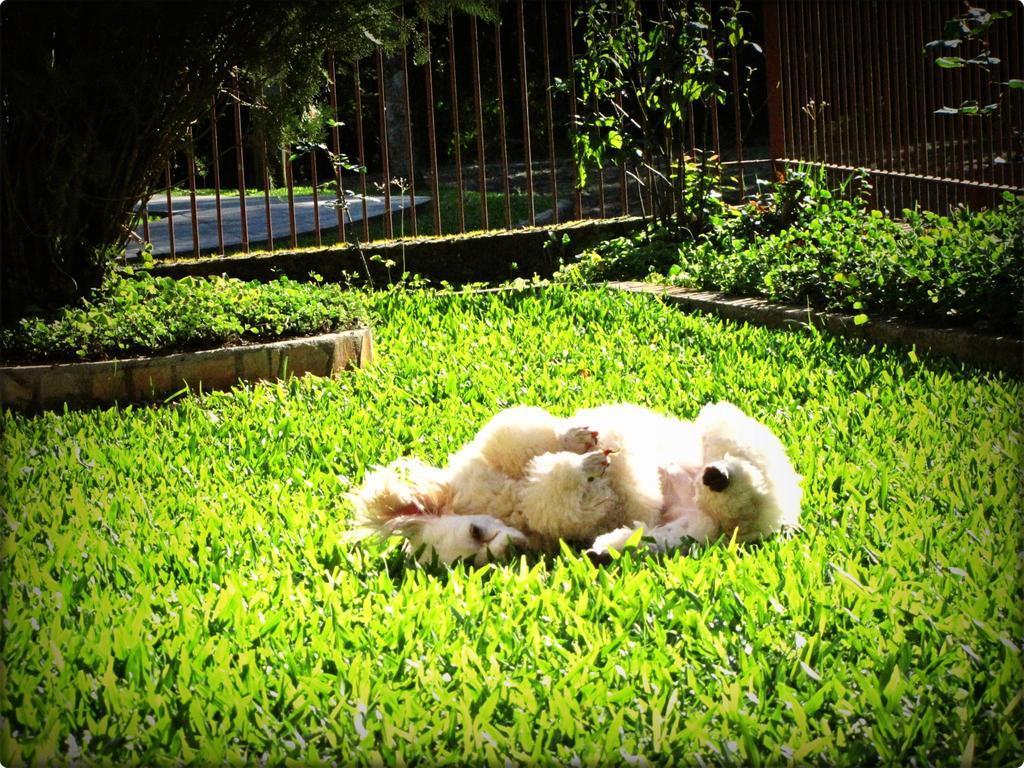Describe this image in one or two sentences. In this picture there are two dogs who are lying on the grass. In the background i can see the plants, fencing, road and trees. 